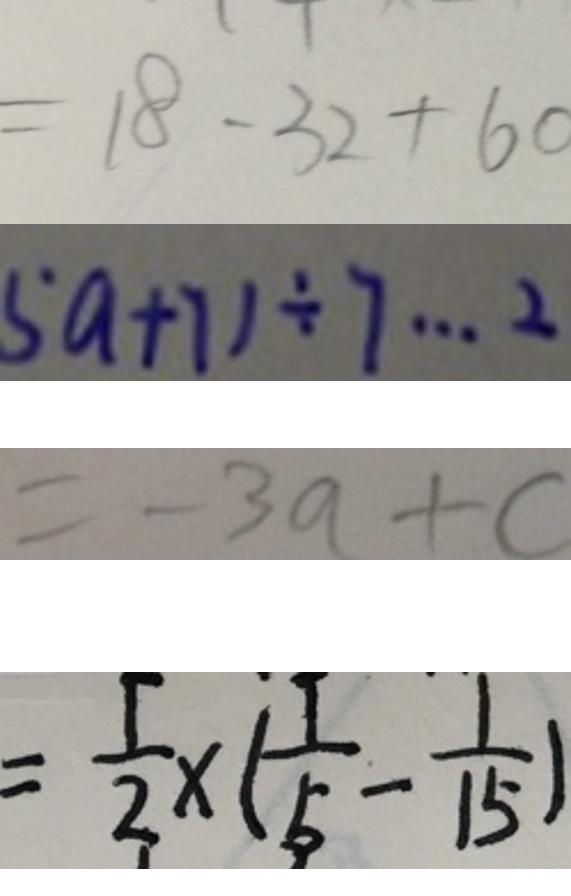<formula> <loc_0><loc_0><loc_500><loc_500>= 1 8 - 3 2 + 6 0 
 5 a + 7 ) \div 7 \cdots 2 
 = - 3 a + c 
 = \frac { 1 } { 2 } \times ( \frac { 1 } { 5 } - \frac { 1 } { 1 5 } )</formula> 